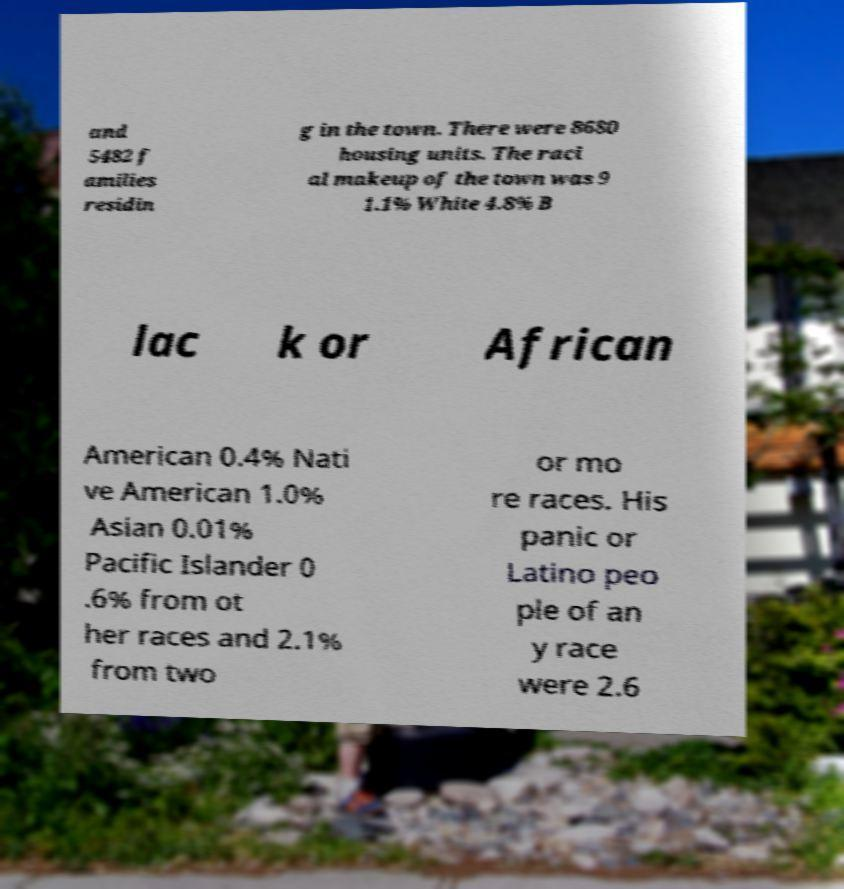I need the written content from this picture converted into text. Can you do that? and 5482 f amilies residin g in the town. There were 8680 housing units. The raci al makeup of the town was 9 1.1% White 4.8% B lac k or African American 0.4% Nati ve American 1.0% Asian 0.01% Pacific Islander 0 .6% from ot her races and 2.1% from two or mo re races. His panic or Latino peo ple of an y race were 2.6 